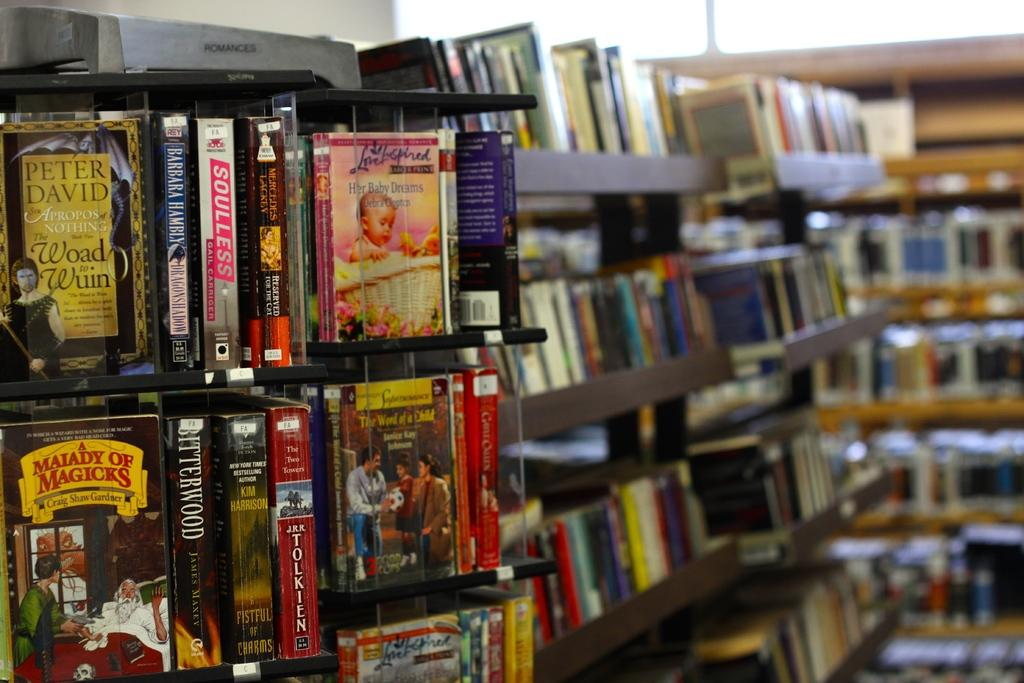What objects can be seen in the image? There are books in the image. How are the books arranged in the image? The books are on racks. How many women are holding onto the cattle in the image? There are no women or cattle present in the image; it only features books on racks. 